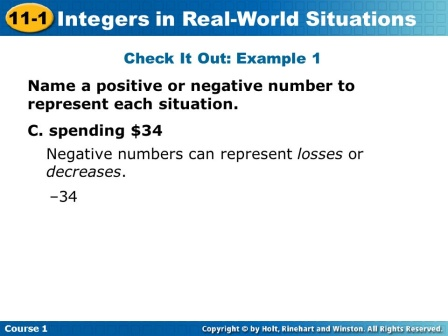Can you tell me what subject this slide pertains to and the key concept it is explaining? This slide pertains to a mathematics lesson, specifically dealing with the topic of integers. It explains how positive and negative numbers can represent real-world situations, such as gains and losses. The example given is 'spending $34', which is represented by the integer -34. What might be other real-world scenarios where negative integers are used, similar to the example provided? Other real-world scenarios where negative integers are used include:
1. **Bank Account:** Withdrawing money from a bank account, which decreases the account balance.
2. **Temperature:** Temperatures below zero degrees Celsius or Fahrenheit.
3. **Debt:** Borrowing money, resulting in a negative balance.
4. **Elevation:** Locations below sea level, like the Dead Sea, represented by negative elevation. Can you create a similar task that involves positive integers? Sure! Here's a similar task involving positive integers:

Name a positive number to represent each situation.

A. Earning $50 – ___

B. A temperature rise of 15 degrees – ___

C. Climbing 200 meters above sea level – ___

D. Depositing $100 into a savings account – ___

Positive integers would be used here to represent gains, increases, or additions. 